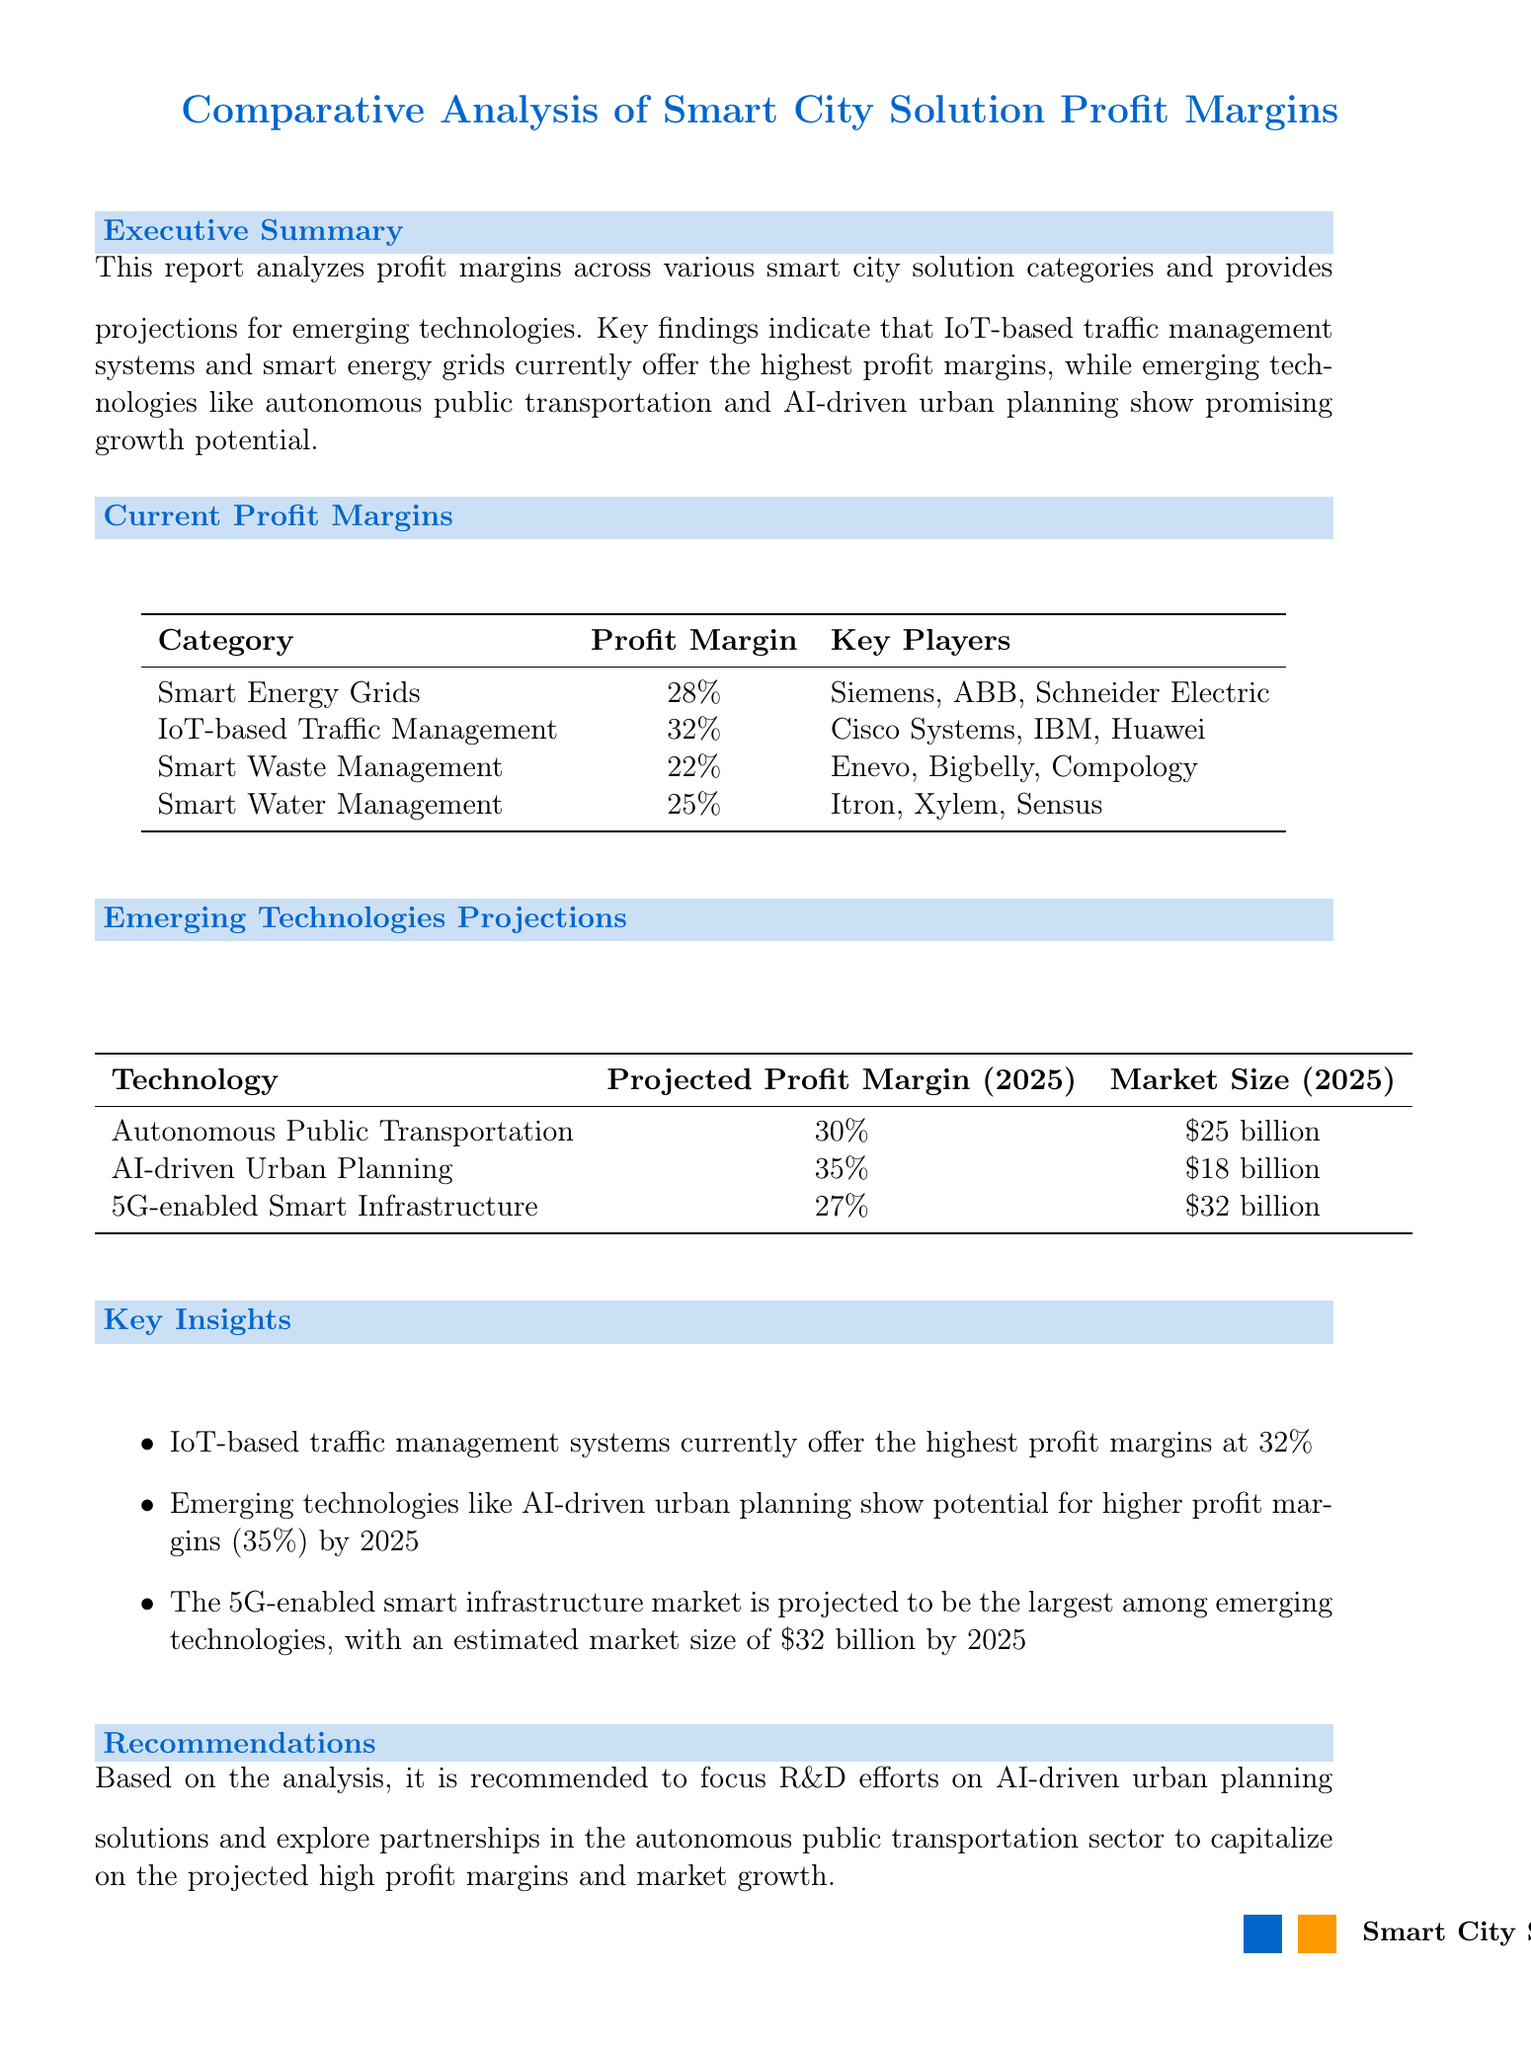What is the title of the report? The title of the report is explicitly stated at the beginning of the document.
Answer: Comparative Analysis of Smart City Solution Profit Margins What is the profit margin for IoT-based traffic management? The profit margin for IoT-based traffic management is listed in the Current Profit Margins section of the report.
Answer: 32% Who are the key players in Smart Energy Grids? The key players are mentioned in the data table for current profit margins.
Answer: Siemens, ABB, Schneider Electric What technology has the highest projected profit margin in 2025? The projected profit margins for emerging technologies are provided, comparing each technology's potential by 2025.
Answer: AI-driven Urban Planning What is the market size projected for 5G-enabled smart infrastructure in 2025? The market size for 5G-enabled smart infrastructure is specifically detailed in the Emerging Technologies Projections section.
Answer: $32 billion Which solution category is recommended for R&D focus? The Recommendations section provides insights on where to allocate R&D efforts based on the analysis.
Answer: AI-driven Urban Planning What is the profit margin for Smart Waste Management? This category's profit margin is included in the Current Profit Margins section of the document.
Answer: 22% What future technology is related to public transportation? Emerging technologies are listed, and one specifically focuses on public transportation.
Answer: Autonomous Public Transportation Which solution category currently provides the lowest profit margin? The profit margins are compared in the Current Profit Margins section, highlighting all categories.
Answer: Smart Waste Management 